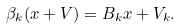<formula> <loc_0><loc_0><loc_500><loc_500>\beta _ { k } ( x + V ) = B _ { k } x + V _ { k } .</formula> 